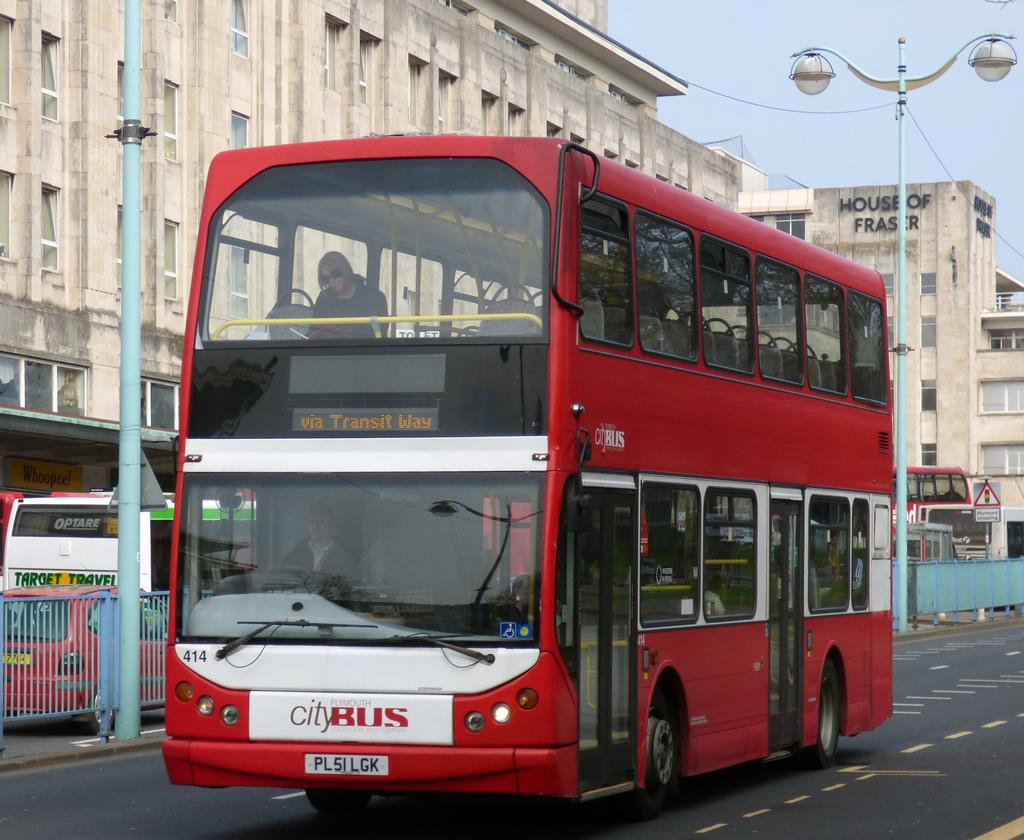<image>
Relay a brief, clear account of the picture shown. A double decker city bus drives down the street. 